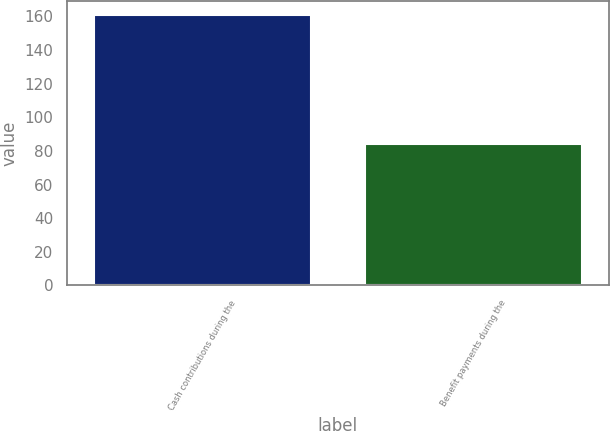Convert chart to OTSL. <chart><loc_0><loc_0><loc_500><loc_500><bar_chart><fcel>Cash contributions during the<fcel>Benefit payments during the<nl><fcel>161<fcel>84<nl></chart> 